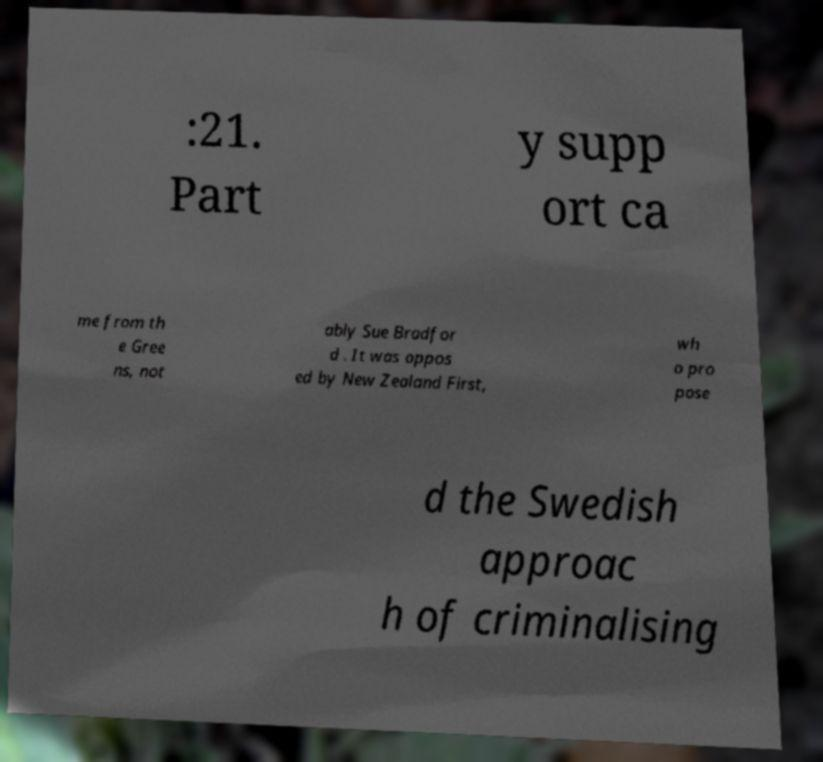Could you extract and type out the text from this image? :21. Part y supp ort ca me from th e Gree ns, not ably Sue Bradfor d . It was oppos ed by New Zealand First, wh o pro pose d the Swedish approac h of criminalising 